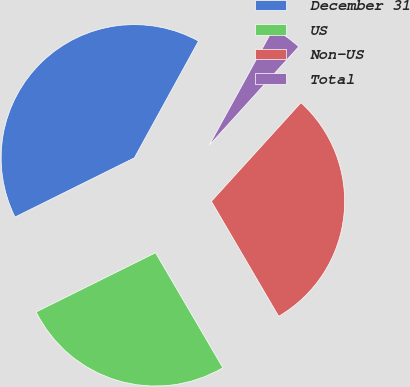Convert chart to OTSL. <chart><loc_0><loc_0><loc_500><loc_500><pie_chart><fcel>December 31<fcel>US<fcel>Non-US<fcel>Total<nl><fcel>40.32%<fcel>26.1%<fcel>29.84%<fcel>3.74%<nl></chart> 